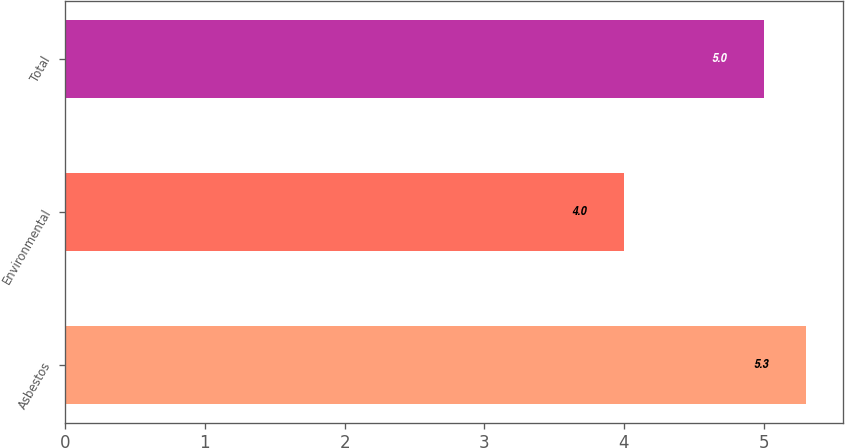Convert chart to OTSL. <chart><loc_0><loc_0><loc_500><loc_500><bar_chart><fcel>Asbestos<fcel>Environmental<fcel>Total<nl><fcel>5.3<fcel>4<fcel>5<nl></chart> 